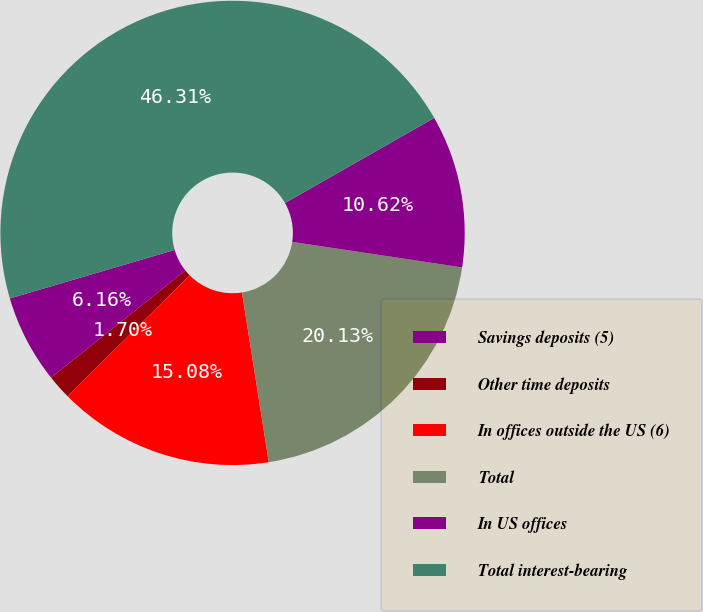Convert chart to OTSL. <chart><loc_0><loc_0><loc_500><loc_500><pie_chart><fcel>Savings deposits (5)<fcel>Other time deposits<fcel>In offices outside the US (6)<fcel>Total<fcel>In US offices<fcel>Total interest-bearing<nl><fcel>6.16%<fcel>1.7%<fcel>15.08%<fcel>20.13%<fcel>10.62%<fcel>46.31%<nl></chart> 